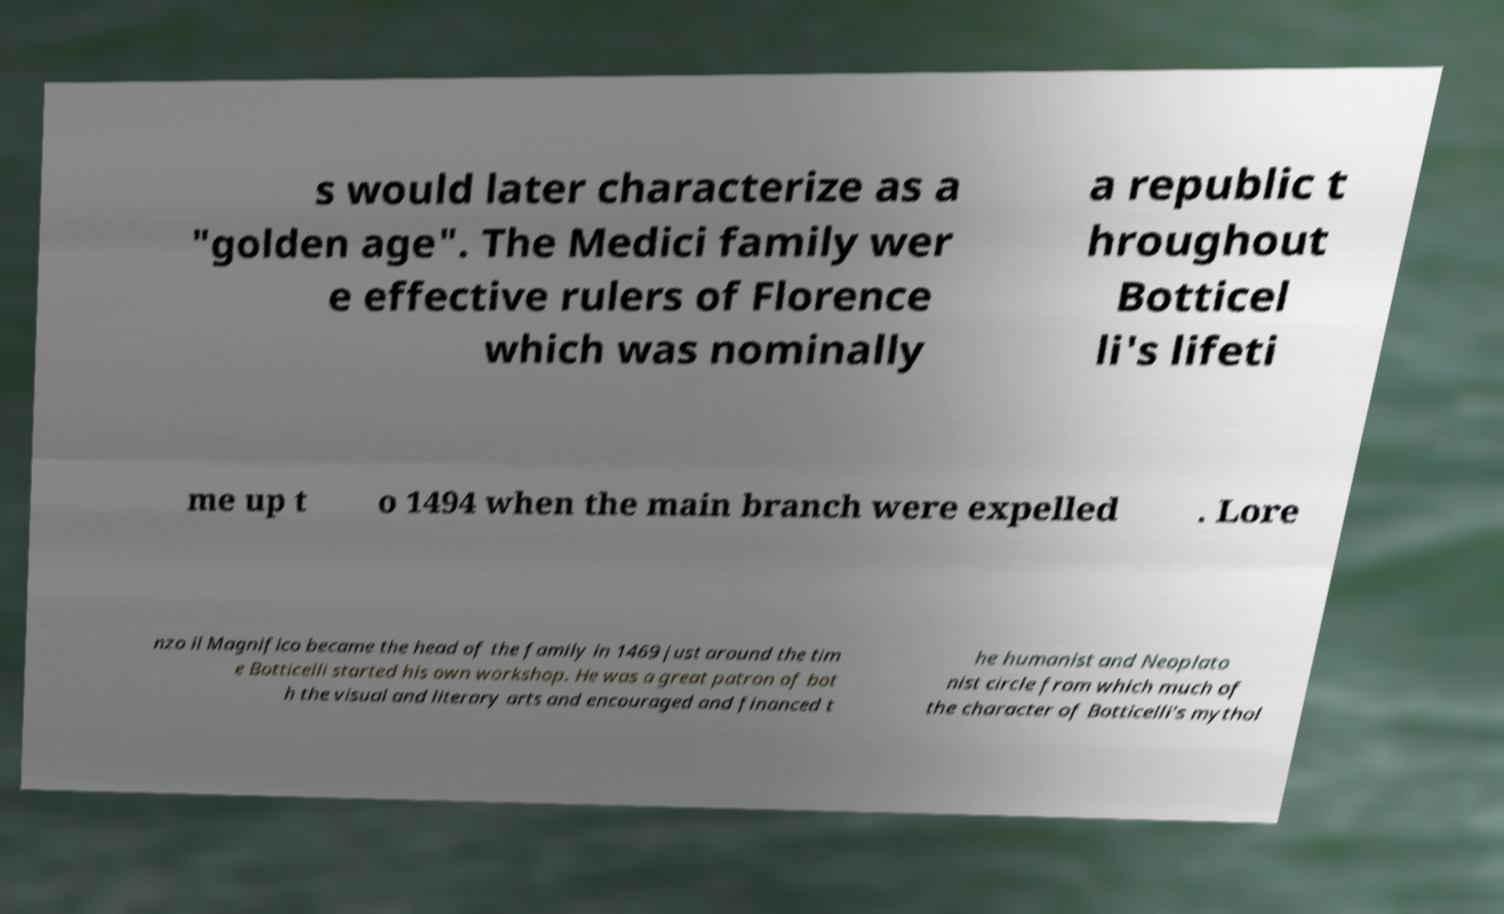What messages or text are displayed in this image? I need them in a readable, typed format. s would later characterize as a "golden age". The Medici family wer e effective rulers of Florence which was nominally a republic t hroughout Botticel li's lifeti me up t o 1494 when the main branch were expelled . Lore nzo il Magnifico became the head of the family in 1469 just around the tim e Botticelli started his own workshop. He was a great patron of bot h the visual and literary arts and encouraged and financed t he humanist and Neoplato nist circle from which much of the character of Botticelli's mythol 